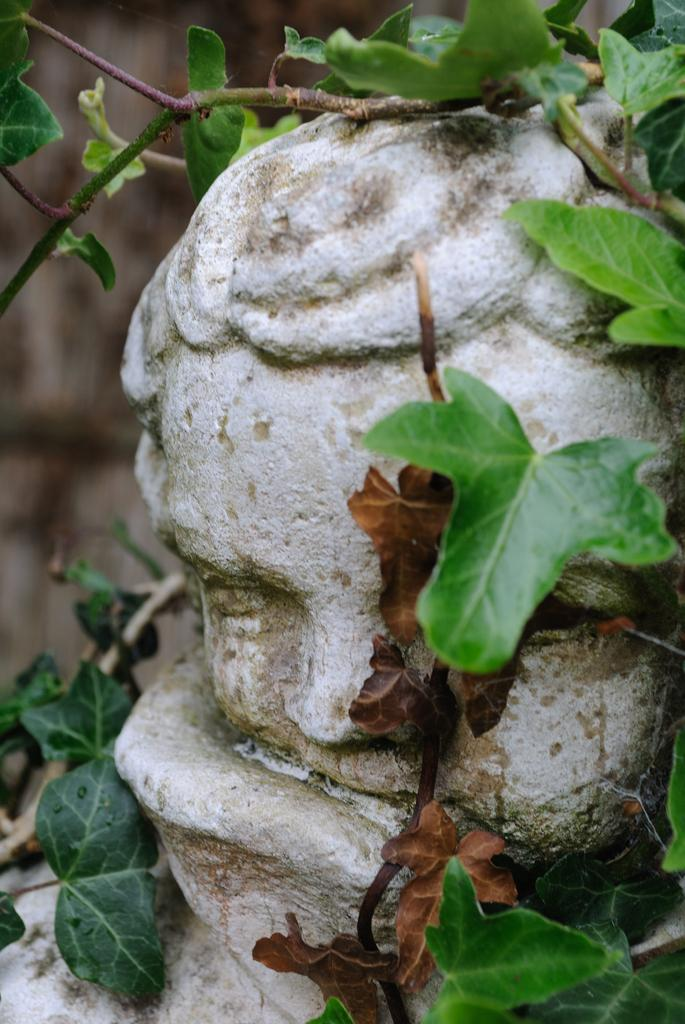What is the main subject of the image? The main subject of the image is a sculpture. What features can be observed on the sculpture? The sculpture has branches and leaves. Can you see a monkey climbing the sculpture in the image? No, there is no monkey present in the image. 